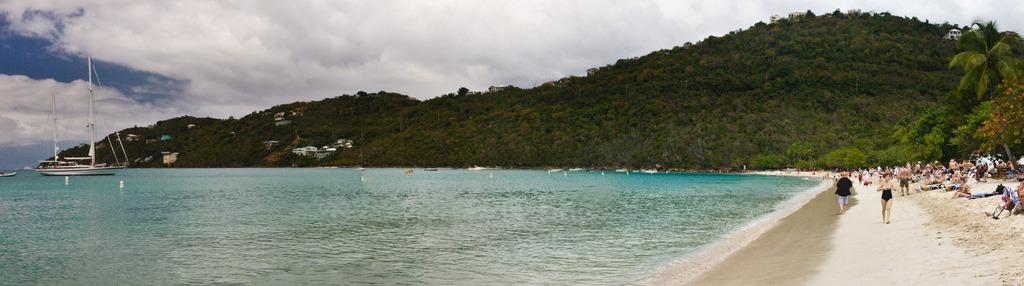What type of terrain is visible in the image? There is sand in the image. Who or what can be seen in the image? There are people in the image. What other natural elements are present in the image? There are trees and water visible in the image. Are there any man-made structures in the image? Yes, there are buildings in the image. What type of vehicle is present in the image? There is a boat in the image. What is visible in the sky in the image? The sky is visible in the image, and there are clouds present. What type of heart can be seen in the image? There is no heart present in the image. How does the image make you feel? The image itself does not have feelings, but it may evoke feelings in the viewer. However, this question cannot be answered definitively based on the provided facts. 